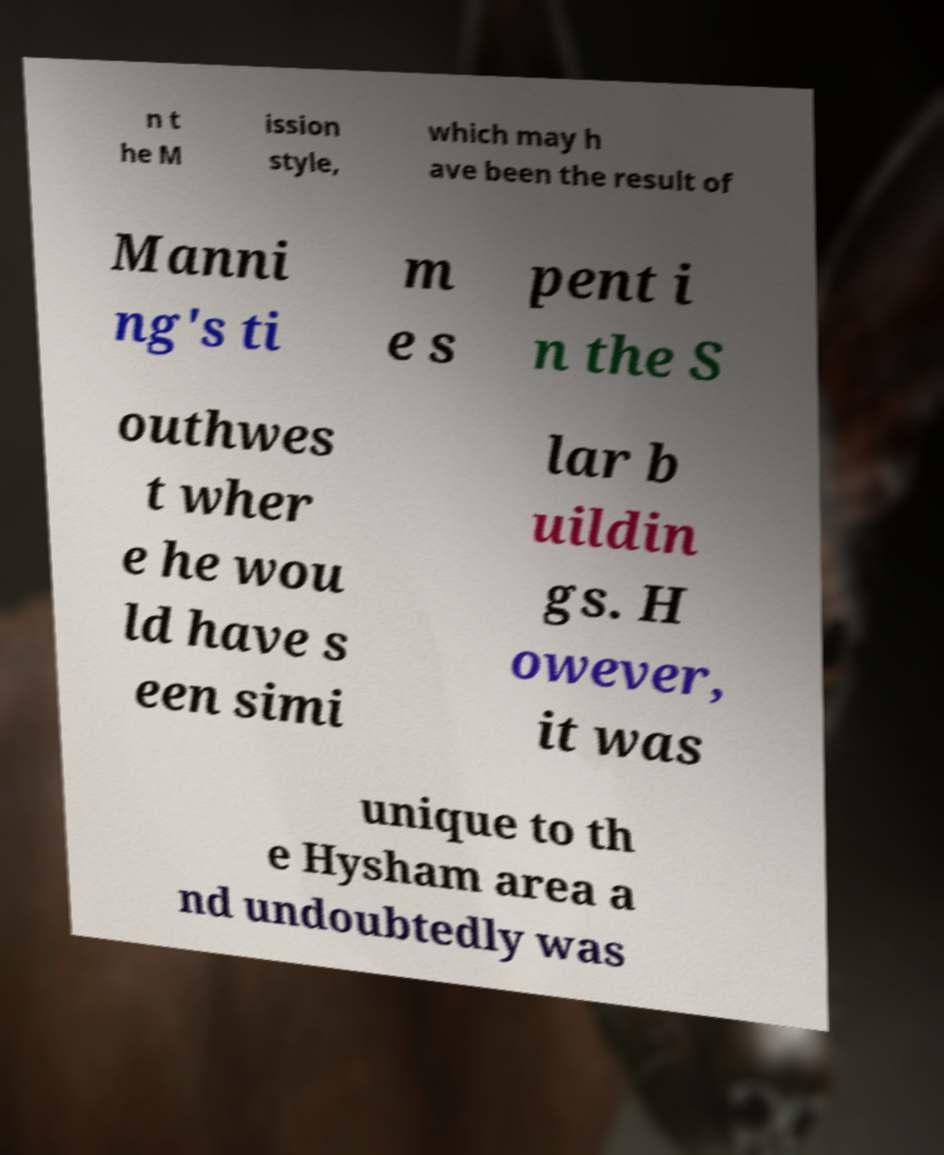Can you accurately transcribe the text from the provided image for me? n t he M ission style, which may h ave been the result of Manni ng's ti m e s pent i n the S outhwes t wher e he wou ld have s een simi lar b uildin gs. H owever, it was unique to th e Hysham area a nd undoubtedly was 